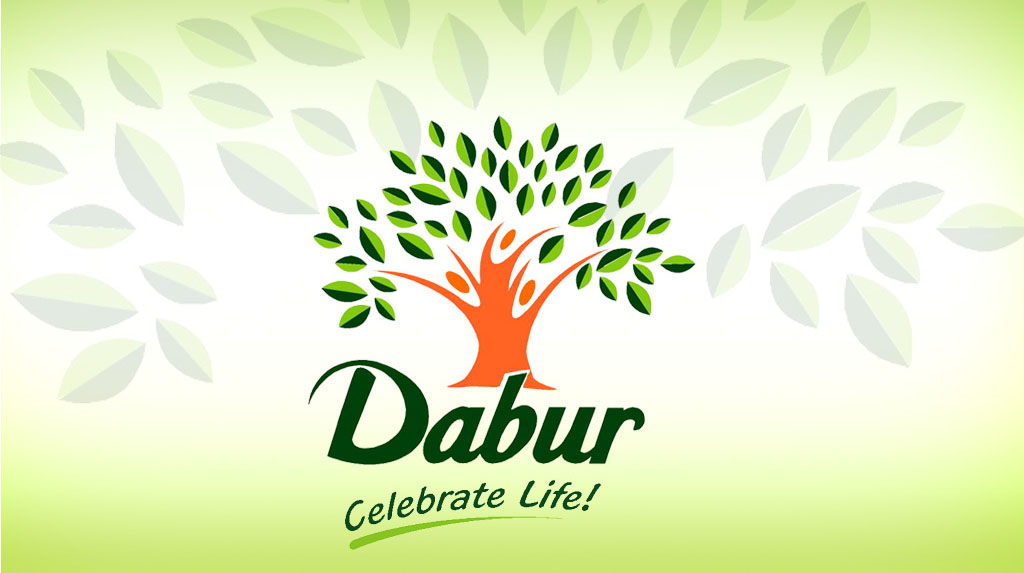How might the human form integrated into the tree symbolize the company's approach to its products or services? The imagery of a human form merged with a tree artistically conveys deep themes of unity between humanity and nature. It suggests that the company values sustainability and views its customers and the environment as inherently connected. This symbolism likely indicates that their products are designed to be eco-friendly, promoting well-being and environmental health together. The implication that the company seeks to nurture and sustain its clients, in the same way a tree supports its ecosystem, highlights a commitment to ethical business practices and a drive to foster life. 